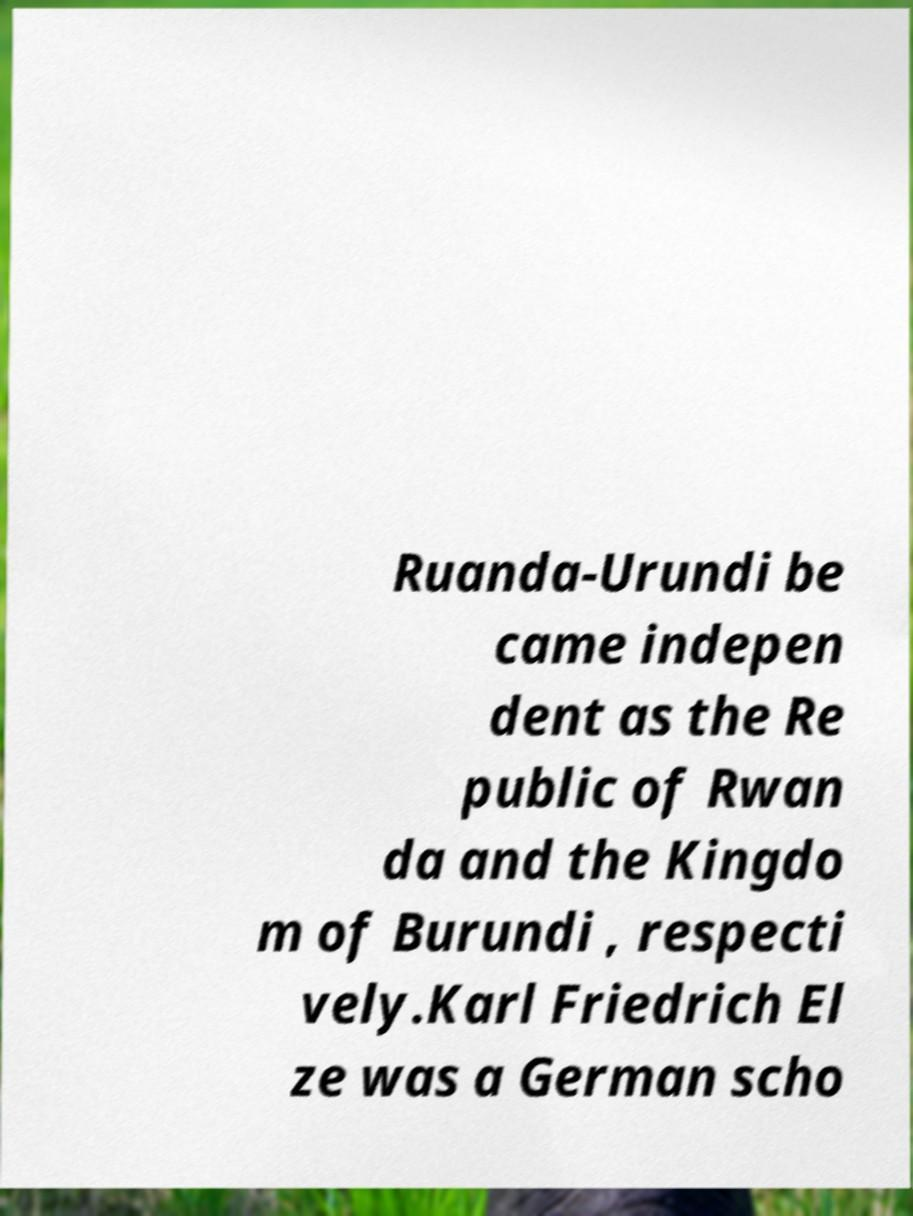Can you read and provide the text displayed in the image?This photo seems to have some interesting text. Can you extract and type it out for me? Ruanda-Urundi be came indepen dent as the Re public of Rwan da and the Kingdo m of Burundi , respecti vely.Karl Friedrich El ze was a German scho 